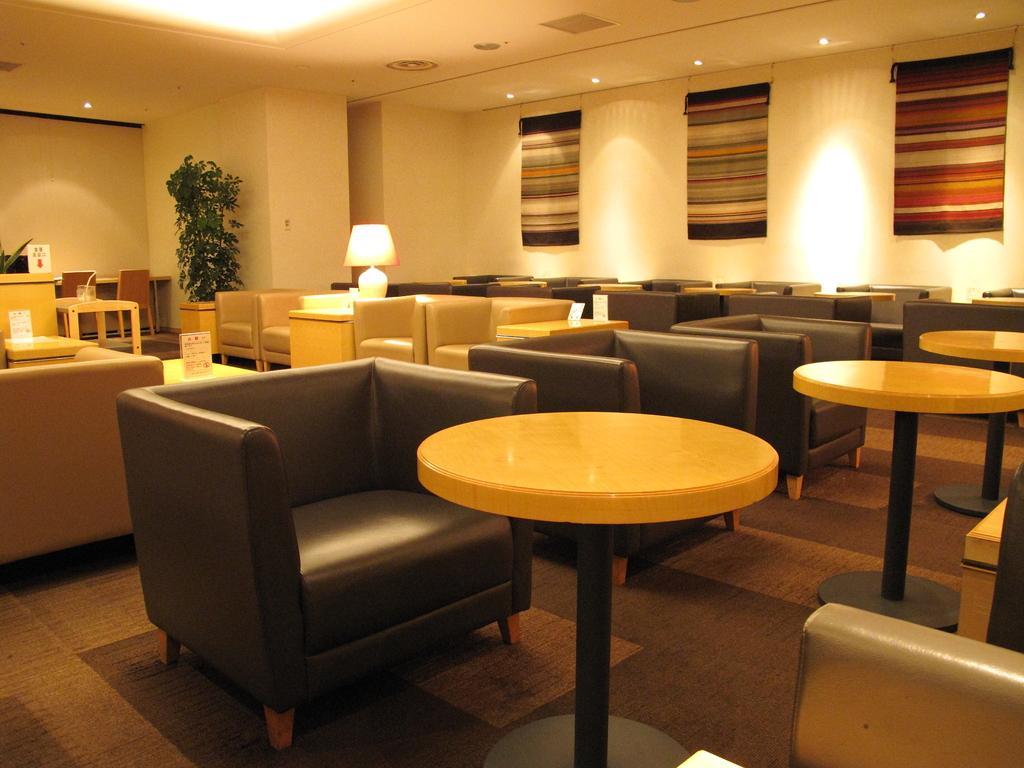In one or two sentences, can you explain what this image depicts? In this image we can see a couch,table and a flower pot. In the background we can see a wall and a lamp on the table. There are curtains on the wall. 